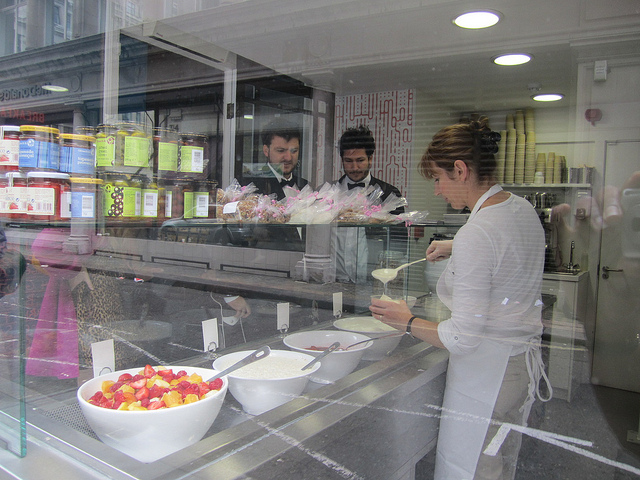What types of food items can you identify in the store? In the glass display, there are two large bowls, one with strawberries and the other seemingly with mixed fruit. Behind the glass, various jars and containers are visible, and these could contain ingredients or prepared food products such as jams, pickles, or spreads. 